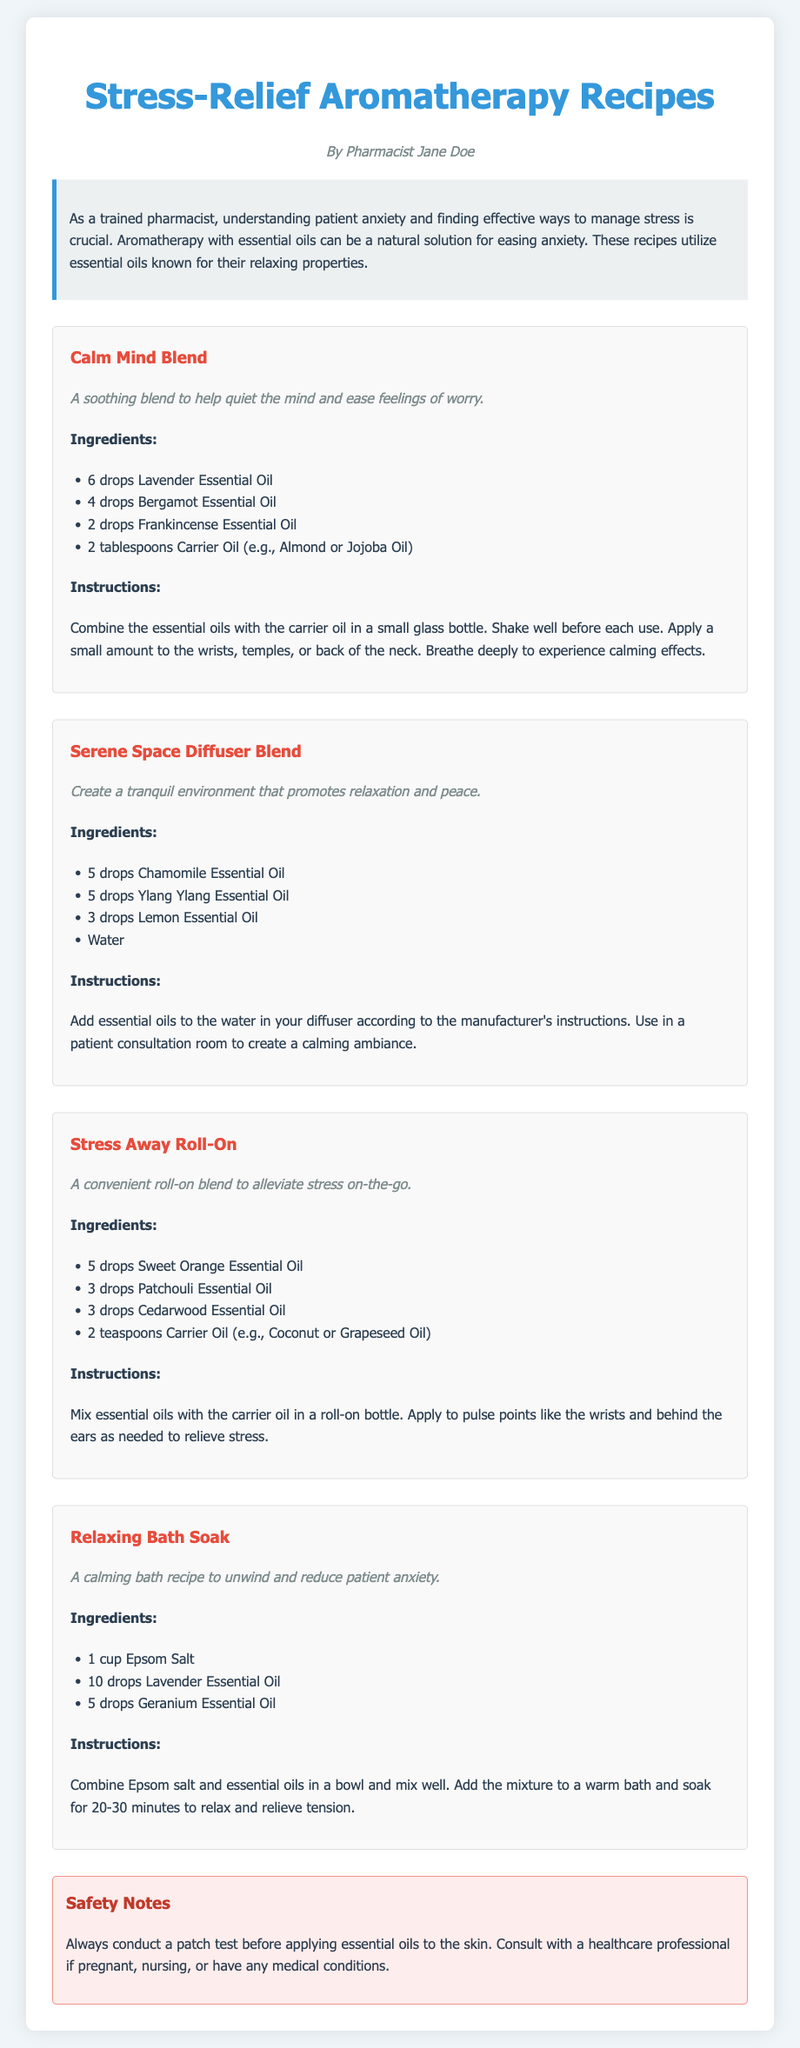What is the title of the document? The title of the document is prominently displayed at the top of the page.
Answer: Stress-Relief Aromatherapy Recipes Who is the author of the recipes? The author is mentioned below the title of the document.
Answer: Pharmacist Jane Doe How many drops of Lavender Essential Oil are in the Calm Mind Blend? The recipe lists the amount of each essential oil needed for the blend.
Answer: 6 drops What is a key ingredient in the Relaxing Bath Soak? The recipe specifies the ingredients used in the bath soak.
Answer: Epsom Salt What essential oil is used in the Serene Space Diffuser Blend for a tranquil environment? Essential oils used in the diffuser blend are listed in the recipe section.
Answer: Chamomile Essential Oil How long should one soak in the Relaxing Bath Soak? The instructions describe the recommended duration for the bath soak.
Answer: 20-30 minutes What should be done before applying essential oils to the skin? The safety notes section outlines precautions that should be taken.
Answer: Conduct a patch test Which essential oil is included in the Stress Away Roll-On? The ingredients for the roll-on blend are specified in the recipe section.
Answer: Sweet Orange Essential Oil 